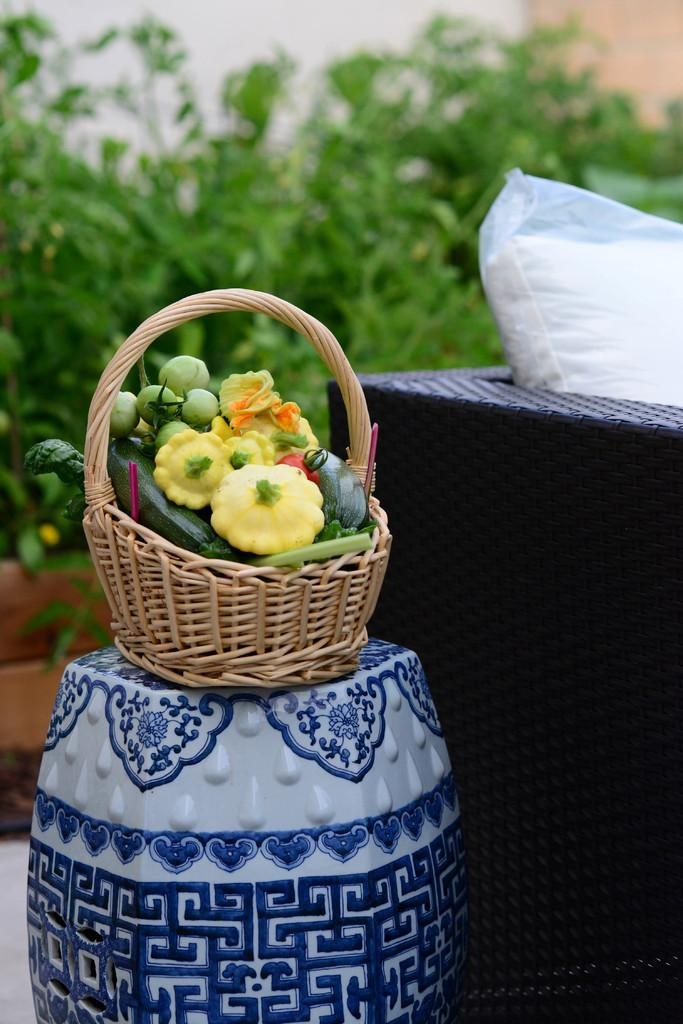What is in the basket that is visible in the image? There is a basket of vegetables in the image. Where is the basket of vegetables located? The basket of vegetables is on top of a stool. What type of furniture is beside the stool? There is a sofa in the image, and the stool is beside the sofa. What can be seen behind the sofa? There are plants behind the sofa. What type of polish is being applied to the desk in the image? There is no desk or polish present in the image. How many cacti are visible in the image? There are no cacti visible in the image. 